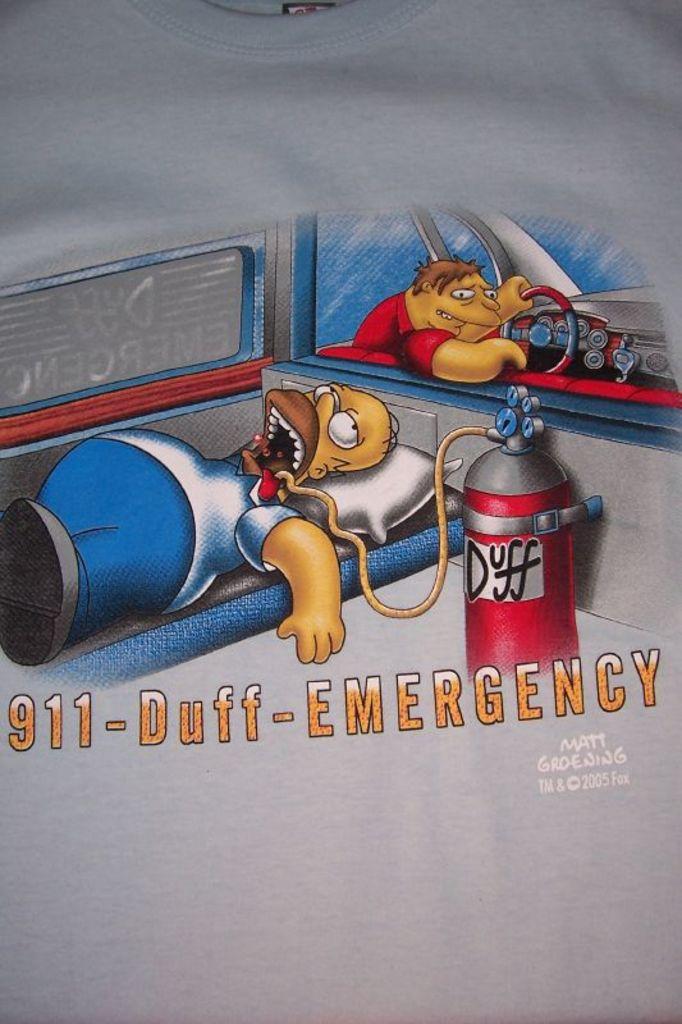What kind of emergency is this?
Make the answer very short. Duff. What year was this shirt made?
Offer a very short reply. 2005. 